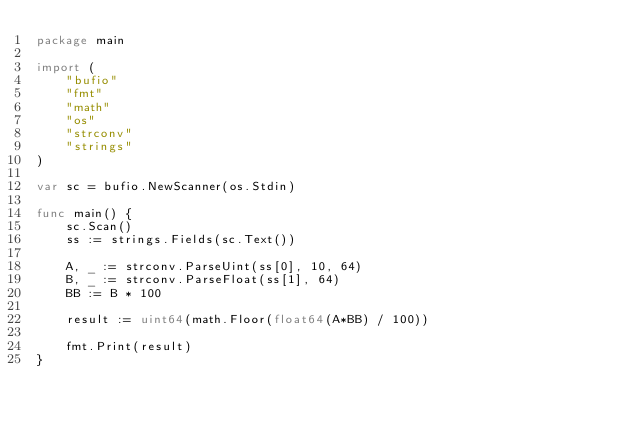Convert code to text. <code><loc_0><loc_0><loc_500><loc_500><_Go_>package main

import (
	"bufio"
	"fmt"
	"math"
	"os"
	"strconv"
	"strings"
)

var sc = bufio.NewScanner(os.Stdin)

func main() {
	sc.Scan()
	ss := strings.Fields(sc.Text())

	A, _ := strconv.ParseUint(ss[0], 10, 64)
	B, _ := strconv.ParseFloat(ss[1], 64)
	BB := B * 100

	result := uint64(math.Floor(float64(A*BB) / 100))

	fmt.Print(result)
}
</code> 